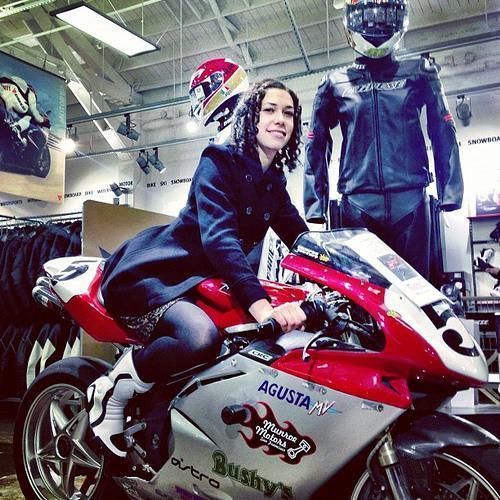How many people are visible?
Give a very brief answer. 1. How many helmets are on display?
Give a very brief answer. 2. 